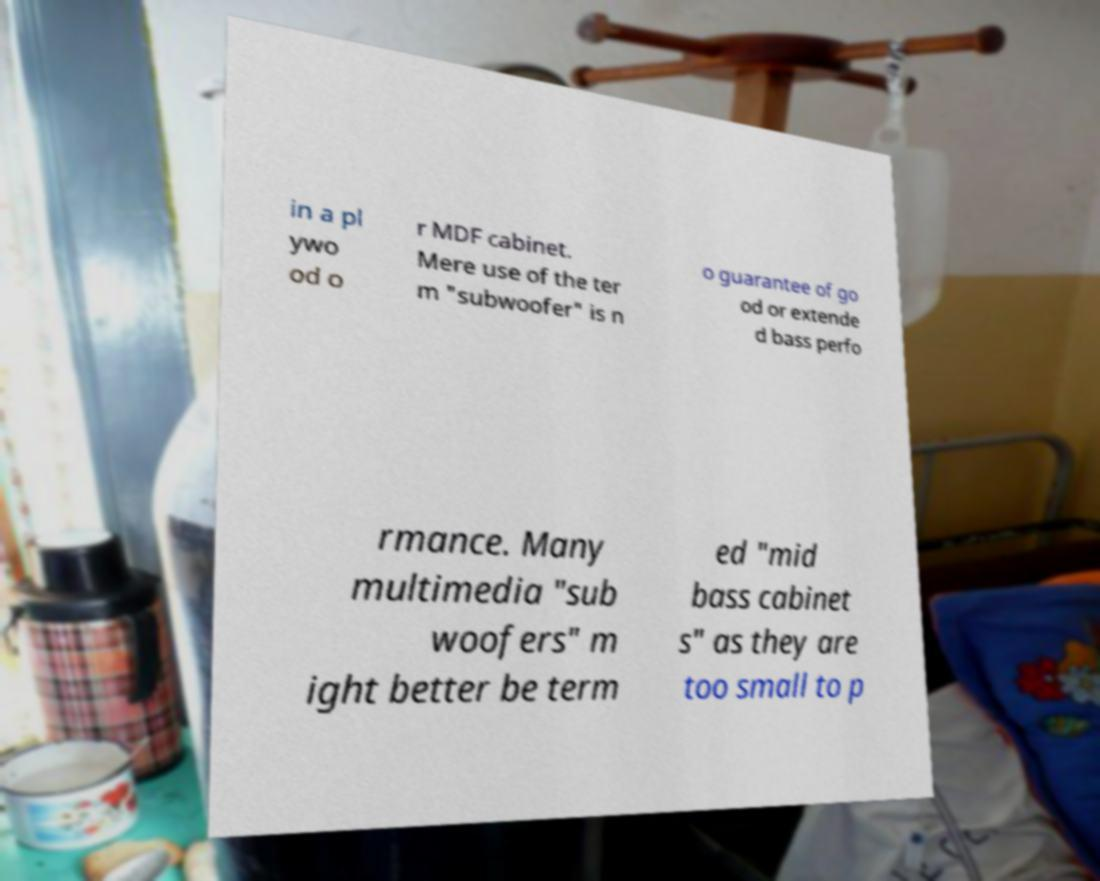What messages or text are displayed in this image? I need them in a readable, typed format. in a pl ywo od o r MDF cabinet. Mere use of the ter m "subwoofer" is n o guarantee of go od or extende d bass perfo rmance. Many multimedia "sub woofers" m ight better be term ed "mid bass cabinet s" as they are too small to p 